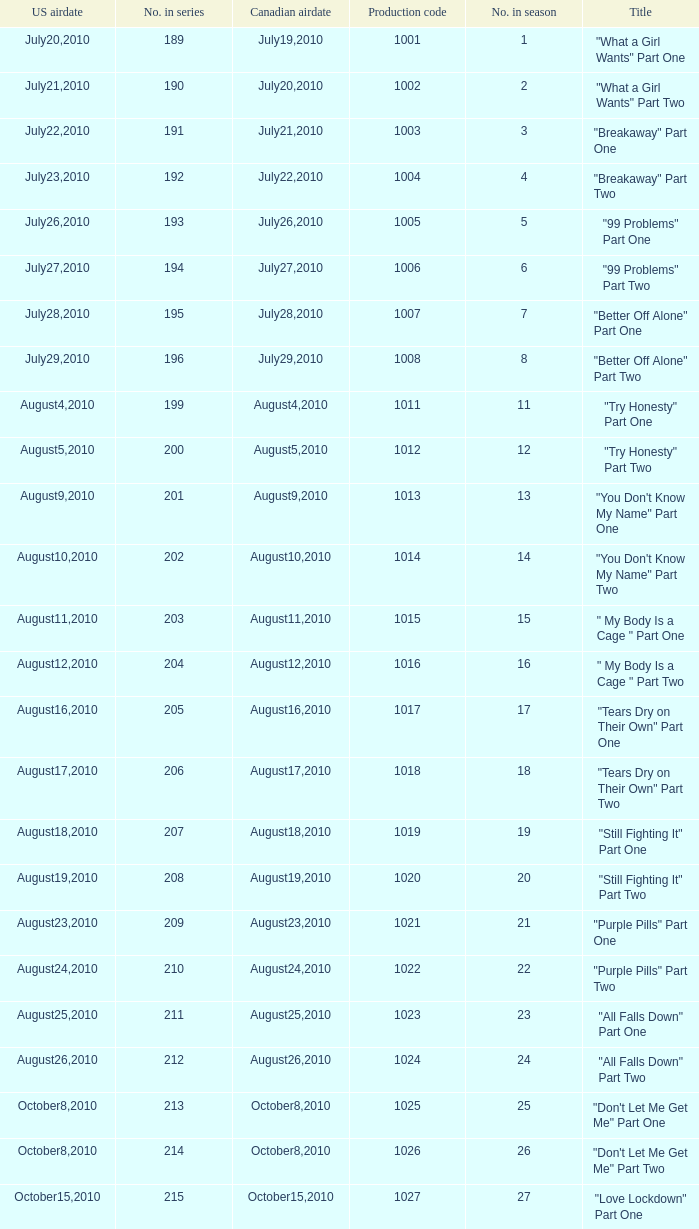How many titles had production code 1040? 1.0. Help me parse the entirety of this table. {'header': ['US airdate', 'No. in series', 'Canadian airdate', 'Production code', 'No. in season', 'Title'], 'rows': [['July20,2010', '189', 'July19,2010', '1001', '1', '"What a Girl Wants" Part One'], ['July21,2010', '190', 'July20,2010', '1002', '2', '"What a Girl Wants" Part Two'], ['July22,2010', '191', 'July21,2010', '1003', '3', '"Breakaway" Part One'], ['July23,2010', '192', 'July22,2010', '1004', '4', '"Breakaway" Part Two'], ['July26,2010', '193', 'July26,2010', '1005', '5', '"99 Problems" Part One'], ['July27,2010', '194', 'July27,2010', '1006', '6', '"99 Problems" Part Two'], ['July28,2010', '195', 'July28,2010', '1007', '7', '"Better Off Alone" Part One'], ['July29,2010', '196', 'July29,2010', '1008', '8', '"Better Off Alone" Part Two'], ['August4,2010', '199', 'August4,2010', '1011', '11', '"Try Honesty" Part One'], ['August5,2010', '200', 'August5,2010', '1012', '12', '"Try Honesty" Part Two'], ['August9,2010', '201', 'August9,2010', '1013', '13', '"You Don\'t Know My Name" Part One'], ['August10,2010', '202', 'August10,2010', '1014', '14', '"You Don\'t Know My Name" Part Two'], ['August11,2010', '203', 'August11,2010', '1015', '15', '" My Body Is a Cage " Part One'], ['August12,2010', '204', 'August12,2010', '1016', '16', '" My Body Is a Cage " Part Two'], ['August16,2010', '205', 'August16,2010', '1017', '17', '"Tears Dry on Their Own" Part One'], ['August17,2010', '206', 'August17,2010', '1018', '18', '"Tears Dry on Their Own" Part Two'], ['August18,2010', '207', 'August18,2010', '1019', '19', '"Still Fighting It" Part One'], ['August19,2010', '208', 'August19,2010', '1020', '20', '"Still Fighting It" Part Two'], ['August23,2010', '209', 'August23,2010', '1021', '21', '"Purple Pills" Part One'], ['August24,2010', '210', 'August24,2010', '1022', '22', '"Purple Pills" Part Two'], ['August25,2010', '211', 'August25,2010', '1023', '23', '"All Falls Down" Part One'], ['August26,2010', '212', 'August26,2010', '1024', '24', '"All Falls Down" Part Two'], ['October8,2010', '213', 'October8,2010', '1025', '25', '"Don\'t Let Me Get Me" Part One'], ['October8,2010', '214', 'October8,2010', '1026', '26', '"Don\'t Let Me Get Me" Part Two'], ['October15,2010', '215', 'October15,2010', '1027', '27', '"Love Lockdown" Part One'], ['October22,2010', '216', 'October22,2010', '1028', '28', '"Love Lockdown" Part Two'], ['October29,2010', '217', 'October29,2010', '1029', '29', '"Umbrella" Part One'], ['November5,2010', '218', 'November5,2010', '1030', '30', '"Umbrella" Part Two'], ['November12,2010', '219', 'November12,2010', '1031', '31', '"Halo" Part One'], ['November19,2010', '220', 'November19,2010', '1032', '32', '"Halo" Part Two'], ['February11,2011', '221', 'February11,2011', '1033', '33', '"When Love Takes Over" Part One'], ['February11,2011', '222', 'February11,2011', '1034', '34', '"When Love Takes Over" Part Two'], ['February18,2011', '223', 'February18,2011', '1035', '35', '"The Way We Get By" Part One'], ['February25,2011', '224', 'February25,2011', '1036', '36', '"The Way We Get By" Part Two'], ['March4,2011', '225', 'March4,2011', '1037', '37', '"Jesus, Etc." Part One'], ['March11,2011', '226', 'March11,2011', '1038', '38', '"Jesus, Etc." Part Two'], ['March18,2011', '227', 'March18,2011', '1039', '39', '"Hide and Seek" Part One'], ['March25,2011', '228', 'March25,2011', '1040', '40', '"Hide and Seek" Part Two'], ['April1,2011', '229', 'April1,2011', '1041', '41', '"Chasing Pavements" Part One'], ['April8,2011', '230', 'April8,2011', '1042', '42', '"Chasing Pavements" Part Two'], ['April15,2011', '231', 'April15,2011', '1043', '43', '"Drop the World" Part One']]} 